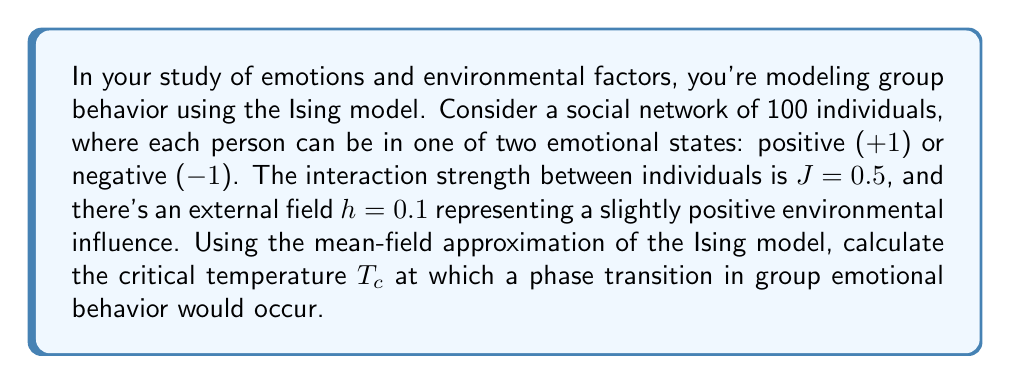What is the answer to this math problem? To solve this problem, we'll use the mean-field approximation of the Ising model and follow these steps:

1) In the mean-field theory, the critical temperature $T_c$ is given by the equation:

   $$T_c = zJ$$

   where $z$ is the coordination number (number of nearest neighbors) and $J$ is the interaction strength.

2) In a fully connected network of 100 individuals, each person interacts with 99 others. So, $z = 99$.

3) We're given that $J = 0.5$.

4) Substituting these values into the equation:

   $$T_c = 99 \times 0.5 = 49.5$$

5) Note that this temperature is in units of $k_B$ (Boltzmann constant), which is often set to 1 in statistical mechanics calculations for simplicity.

6) The external field $h$ doesn't affect the critical temperature in the mean-field approximation, but it would influence the magnetization (average emotional state) of the system.

7) Above this temperature, the system would be in a disordered phase where individual emotions fluctuate randomly. Below this temperature, the system would tend to align towards a common emotional state, either positive or negative.
Answer: $T_c = 49.5$ (in units of $k_B$) 